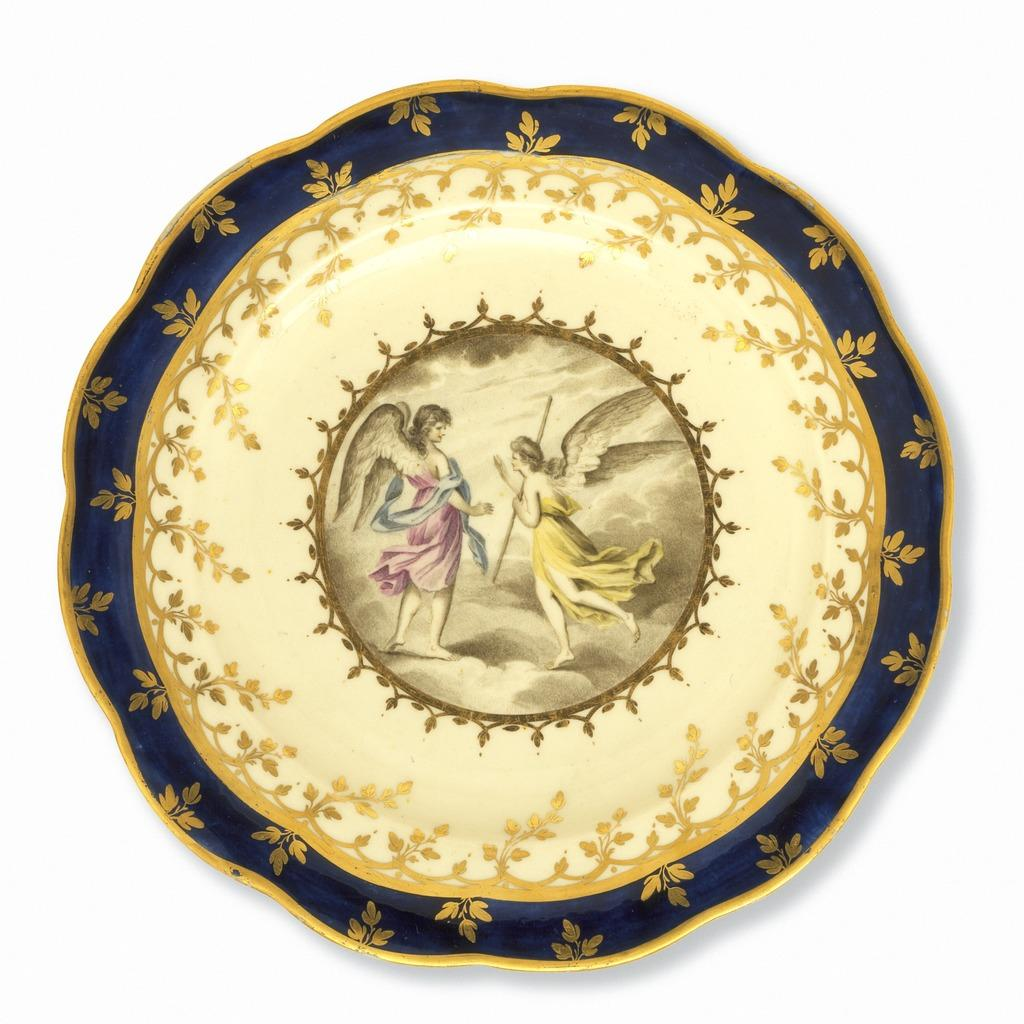What is the main object in the image? There is a cream and golden colored object in the image. What can be seen on the surface of the object? There are pictures on the center of the object. What color is the background of the image? The background of the image is white. What type of grain is being harvested in the image? There is no grain or harvesting activity present in the image. What food item is being prepared in the image? There is no food preparation activity present in the image. 